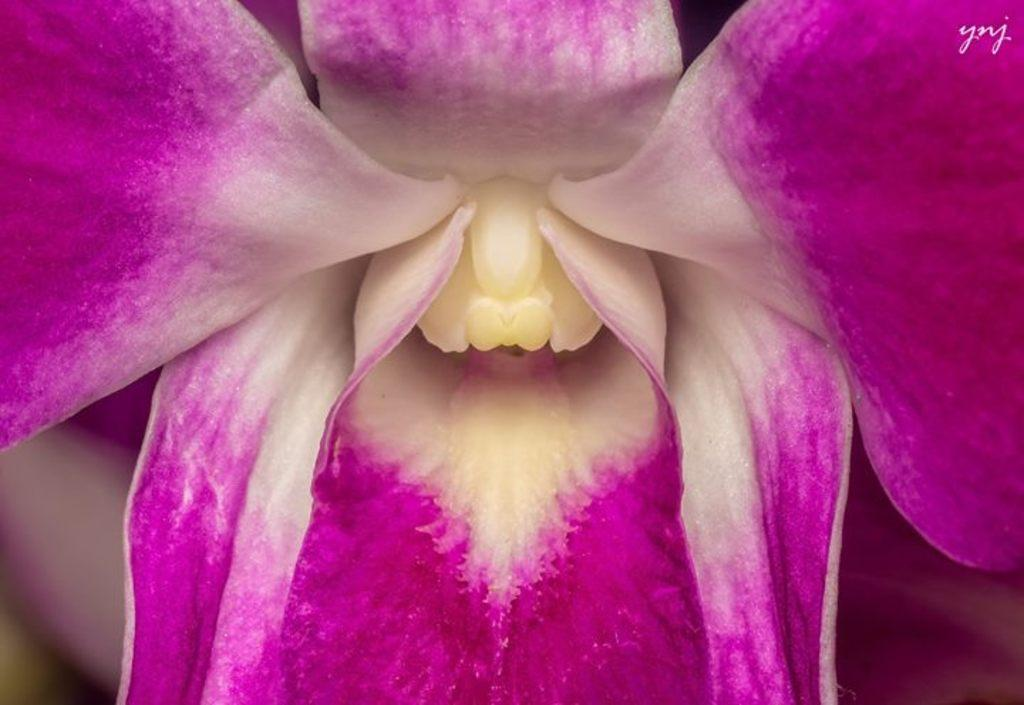What is the main subject in the center of the image? There is a flower in the center of the image. Can you describe the colors of the flower? The flower has pink, white, and cream colors. Where is the text located in the image? The text is on the top right side of the image. What is the mass of the pin holding the flower in the image? There is no pin present in the image, so it is not possible to determine the mass of a pin. 